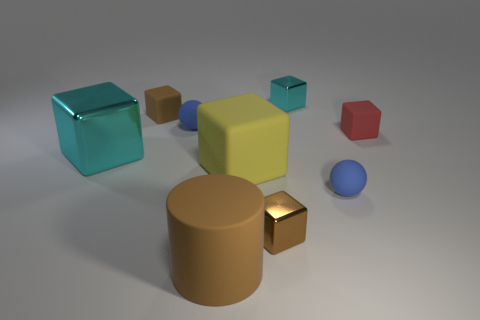There is a ball that is to the right of the brown metallic thing; what is its color?
Make the answer very short. Blue. What is the material of the brown block behind the small blue matte thing to the right of the small cyan shiny object?
Your answer should be very brief. Rubber. The small cyan thing has what shape?
Give a very brief answer. Cube. There is a small cyan thing that is the same shape as the large metal object; what is its material?
Your answer should be very brief. Metal. How many matte balls have the same size as the red object?
Offer a terse response. 2. There is a small metallic block that is behind the small red rubber thing; are there any small shiny objects that are on the right side of it?
Give a very brief answer. No. How many brown things are large cylinders or tiny metal objects?
Provide a short and direct response. 2. What color is the cylinder?
Provide a short and direct response. Brown. What size is the red object that is made of the same material as the large yellow thing?
Make the answer very short. Small. How many other tiny brown metal objects have the same shape as the small brown metal thing?
Your response must be concise. 0. 